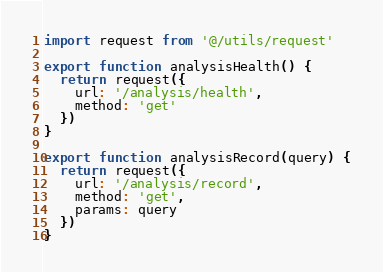Convert code to text. <code><loc_0><loc_0><loc_500><loc_500><_JavaScript_>import request from '@/utils/request'

export function analysisHealth() {
  return request({
    url: '/analysis/health',
    method: 'get'
  })
}

export function analysisRecord(query) {
  return request({
    url: '/analysis/record',
    method: 'get',
    params: query
  })
}
</code> 